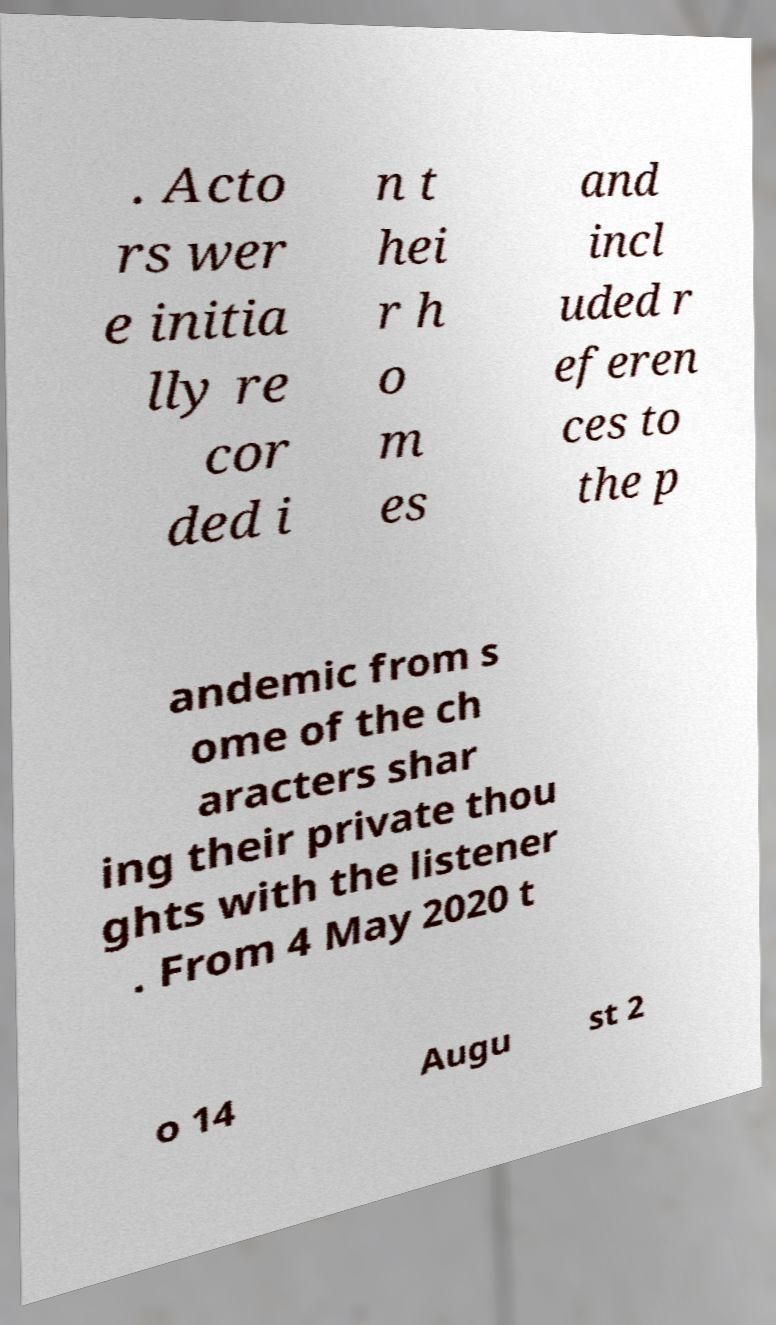Could you assist in decoding the text presented in this image and type it out clearly? . Acto rs wer e initia lly re cor ded i n t hei r h o m es and incl uded r eferen ces to the p andemic from s ome of the ch aracters shar ing their private thou ghts with the listener . From 4 May 2020 t o 14 Augu st 2 